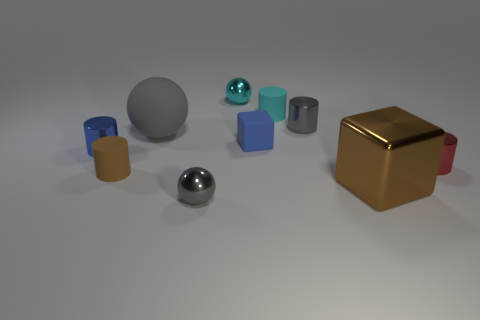Subtract all gray metal cylinders. How many cylinders are left? 4 Subtract all cyan cylinders. How many cylinders are left? 4 Subtract all purple cylinders. Subtract all cyan cubes. How many cylinders are left? 5 Subtract all balls. How many objects are left? 7 Subtract 1 blue blocks. How many objects are left? 9 Subtract all shiny objects. Subtract all cyan cylinders. How many objects are left? 3 Add 5 gray balls. How many gray balls are left? 7 Add 1 large matte spheres. How many large matte spheres exist? 2 